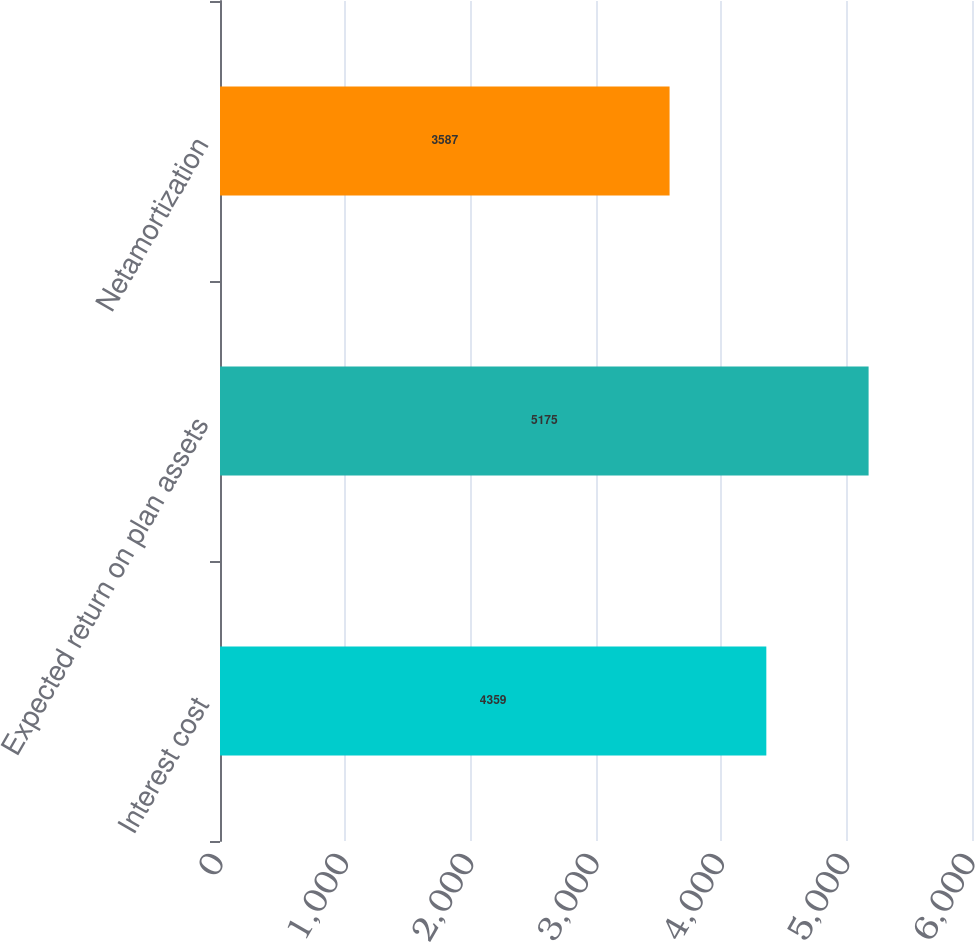<chart> <loc_0><loc_0><loc_500><loc_500><bar_chart><fcel>Interest cost<fcel>Expected return on plan assets<fcel>Netamortization<nl><fcel>4359<fcel>5175<fcel>3587<nl></chart> 